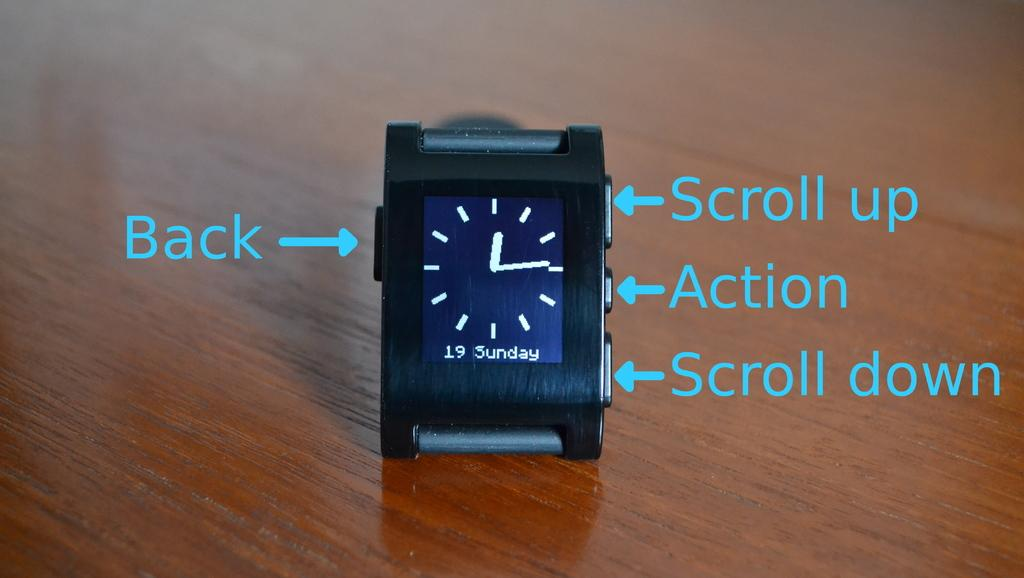<image>
Offer a succinct explanation of the picture presented. A clock set at quarter past 12 which says it's Sunday the 19th. 